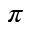Convert formula to latex. <formula><loc_0><loc_0><loc_500><loc_500>\pi</formula> 